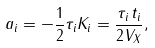<formula> <loc_0><loc_0><loc_500><loc_500>a _ { i } = - \frac { 1 } { 2 } \tau _ { i } K _ { i } = \frac { \tau _ { i } \, t _ { i } } { 2 V _ { X } } ,</formula> 